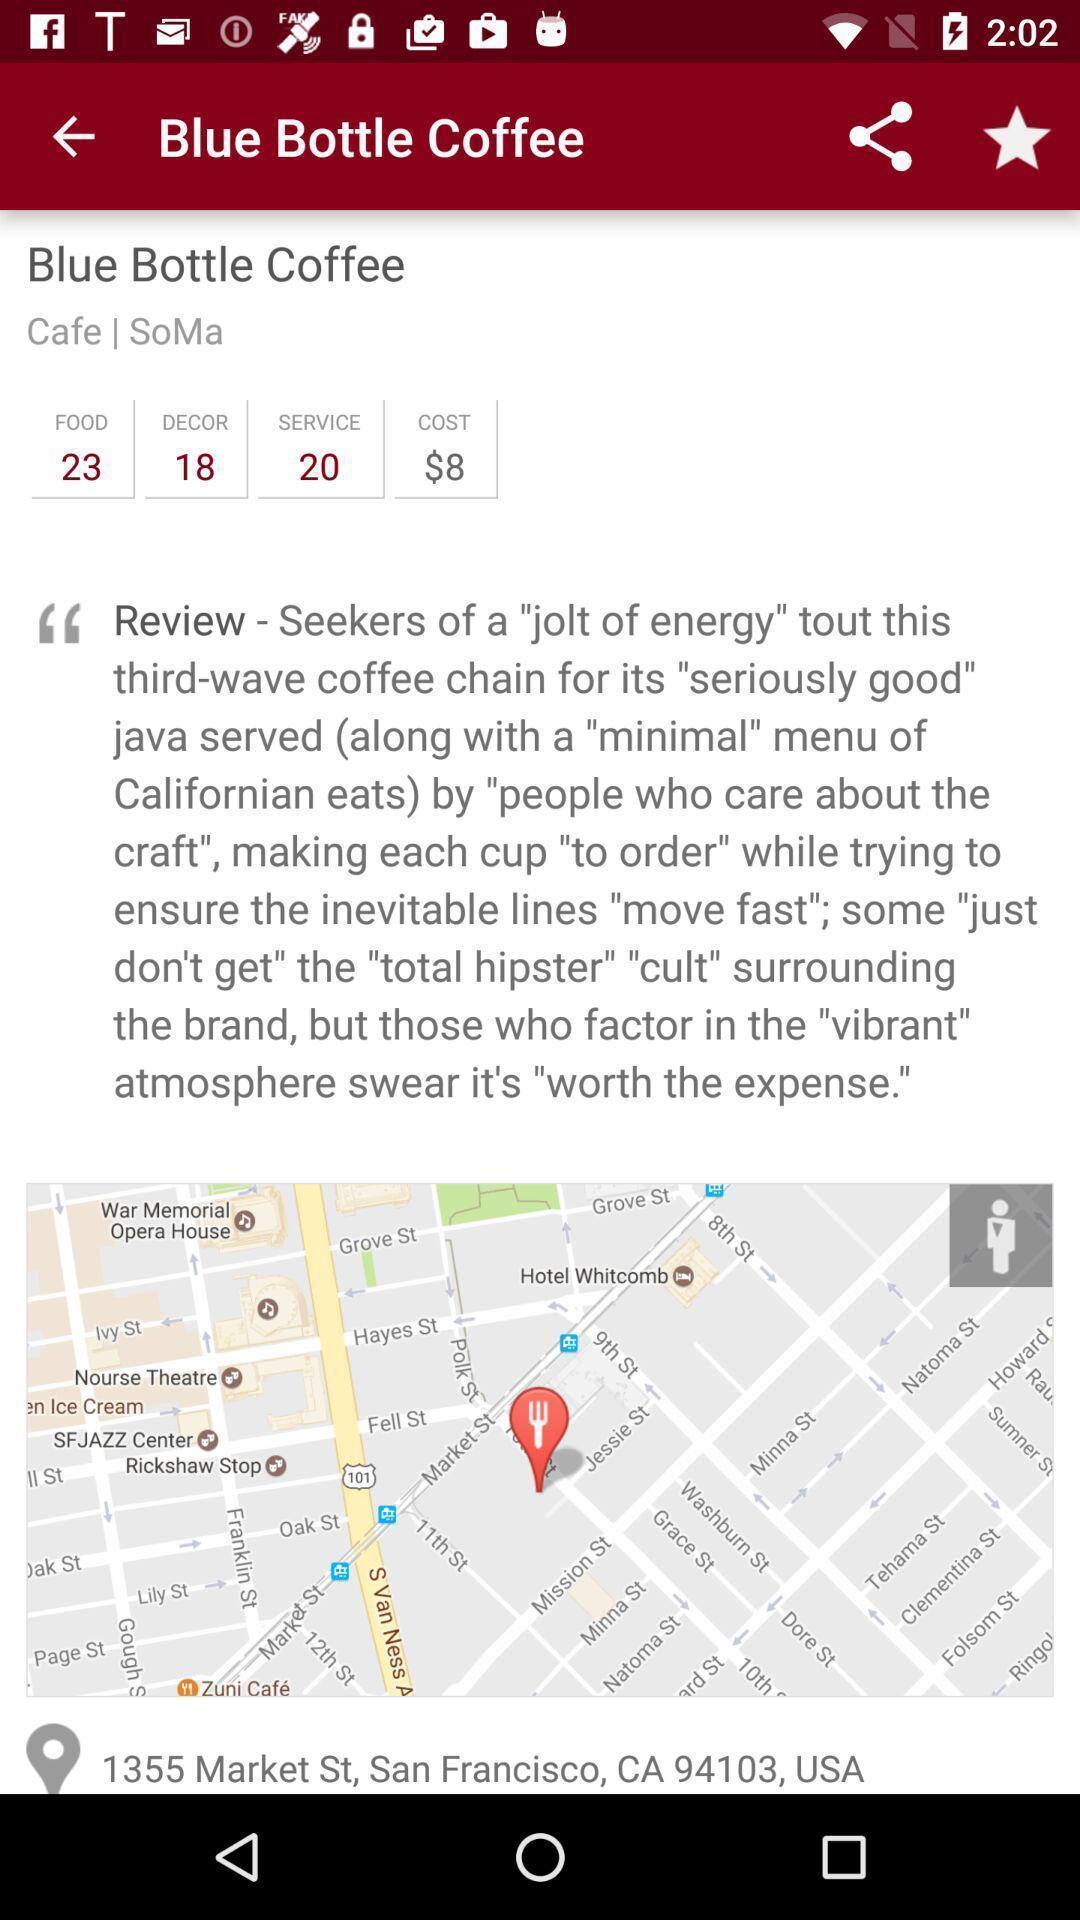What details can you identify in this image? Page showing details of a restaurant. 